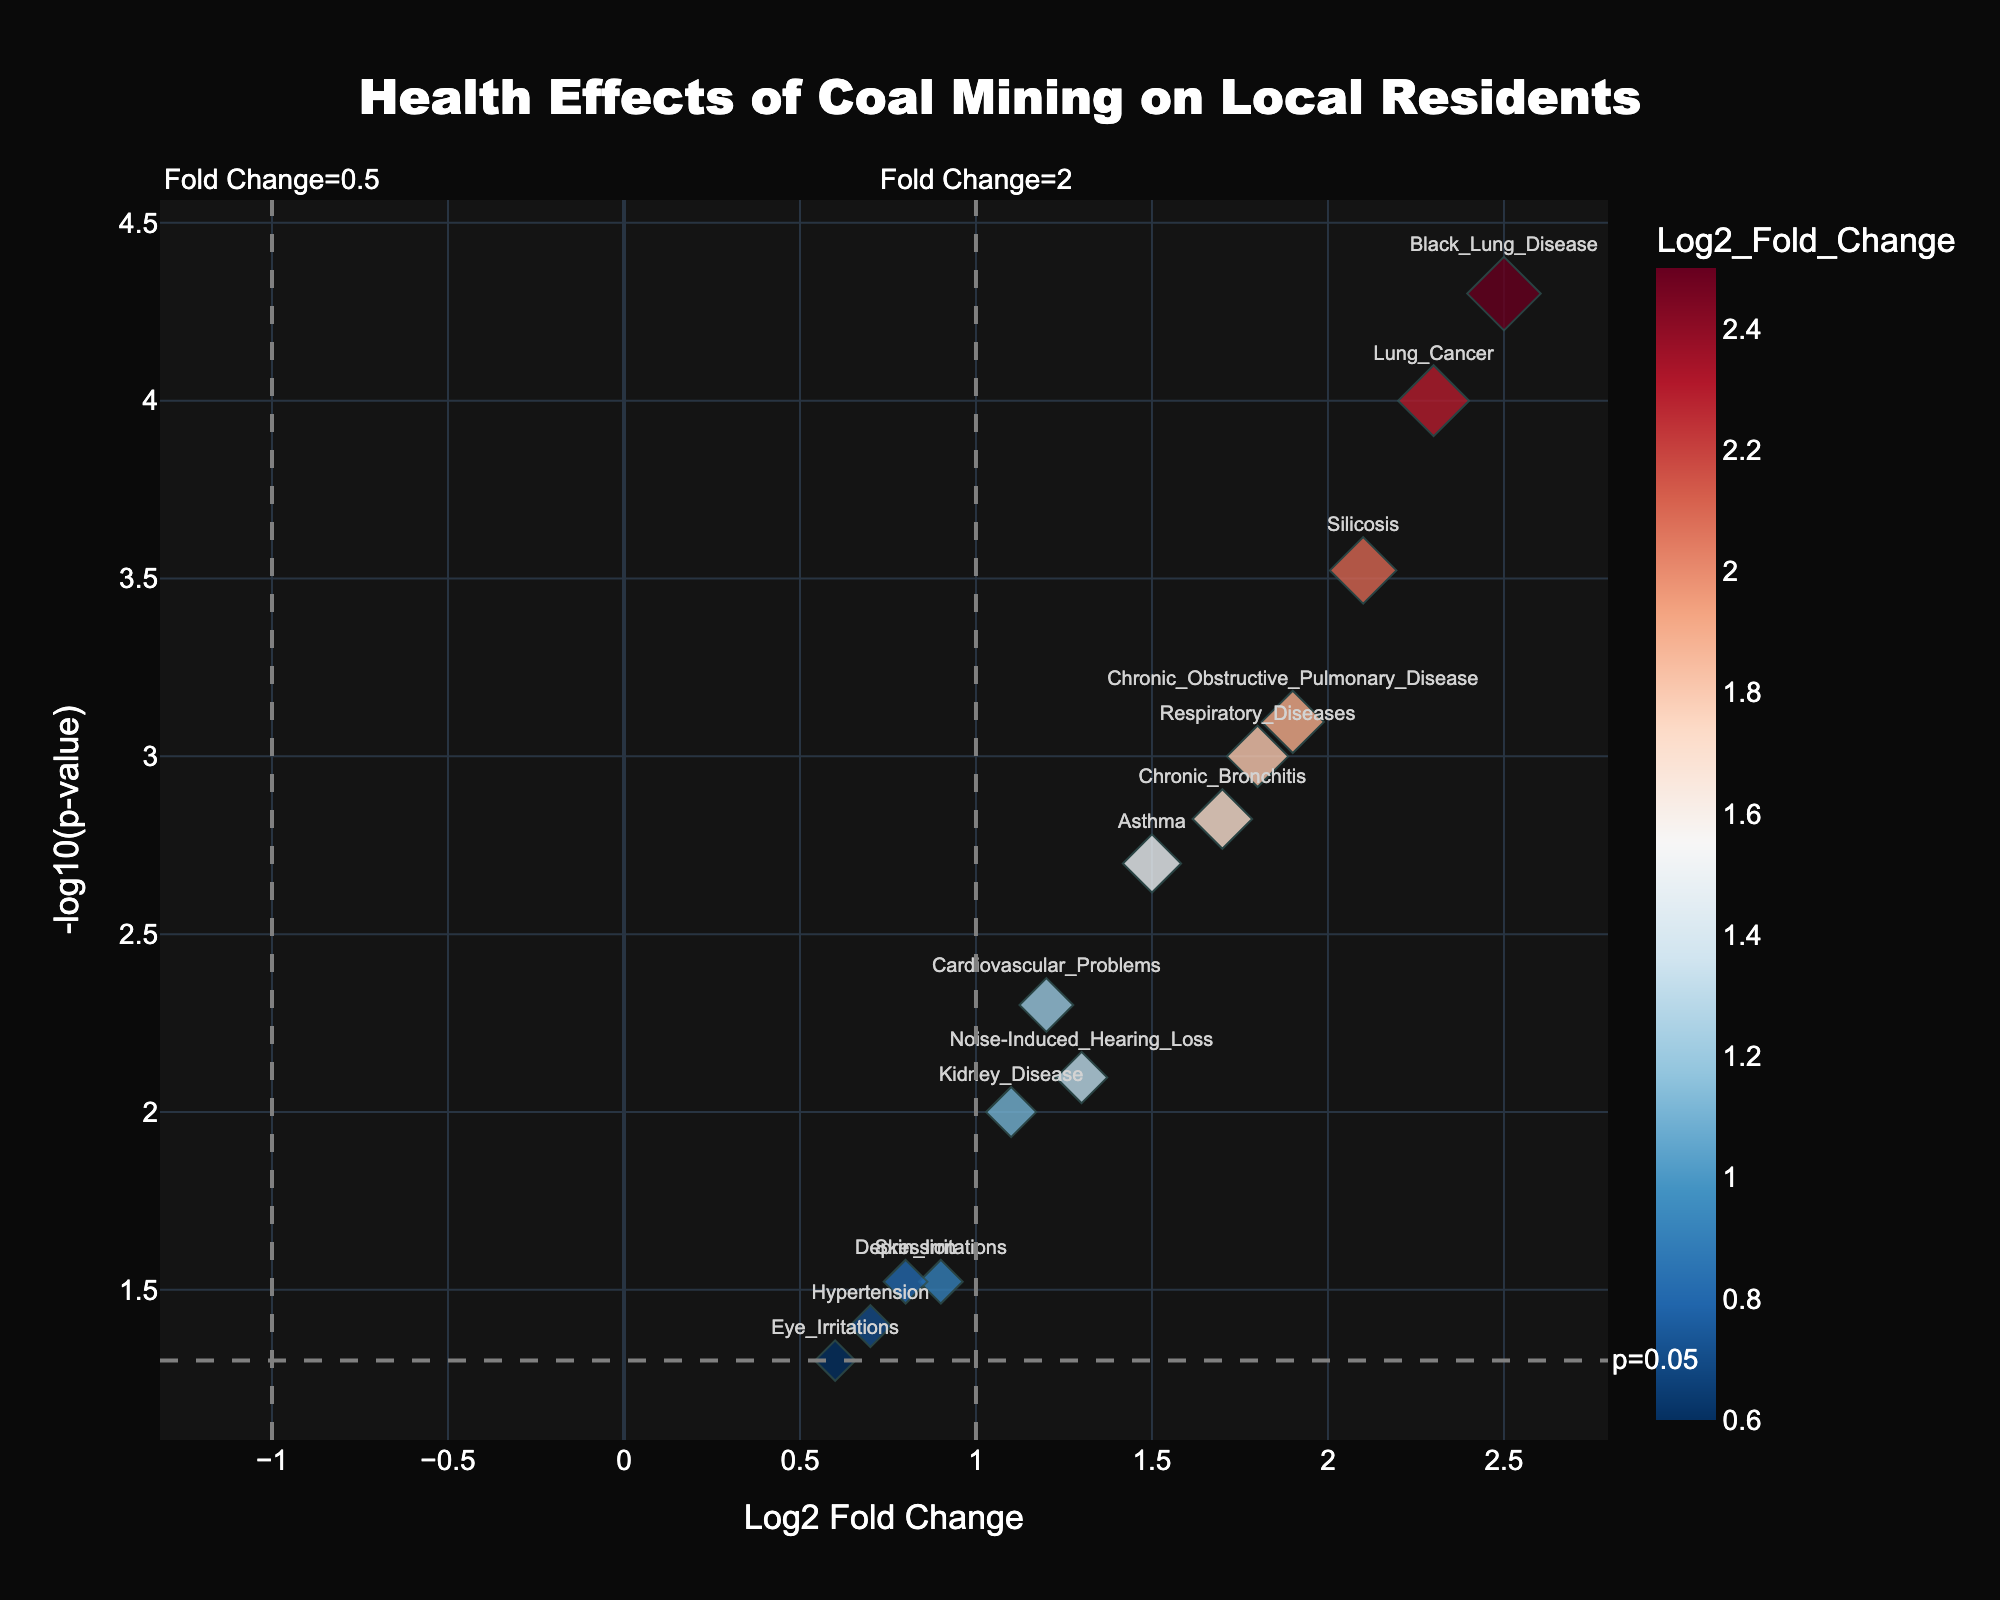What is the title of the plot? The title of the plot is typically displayed at the top of the figure. In this case, it is "Health Effects of Coal Mining on Local Residents" as referenced in the code.
Answer: Health Effects of Coal Mining on Local Residents How many health issues have a p-value less than 0.05? A p-value less than 0.05 is considered statistically significant. By counting the number of data points above the horizontal line labeled "p=0.05", we can determine the number of health issues that meet this criterion.
Answer: 12 Which health issue has the highest magnitude of log2 fold change? The log2 fold change is on the x-axis. The health issue with the highest log2 fold change will be the data point farthest to the right. From the data, this is Black Lung Disease with a log2 fold change of 2.5.
Answer: Black Lung Disease What are the health issues with log2 fold change greater than 2? Data points with log2 fold change > 2 lie to the right of the vertical line labeled "Fold Change=2". These health issues are identified from the figure by their labels.
Answer: Lung Cancer, Black Lung Disease, Silicosis For health issues with a log2 fold change greater than 2, what is their average -log10(p-value)? First identify the health issues with log2 fold change > 2 (Lung Cancer, Black Lung Disease, Silicosis). Then sum their -log10(p-values) and divide by the number of such health issues.
Answer: 3.72 What health issue has the smallest -log10(p-value)? The y-axis shows -log10(p-value), with smaller values lower on the plot. Eye Irritations, which is closest to the x-axis, has the smallest -log10(p-value).
Answer: Eye Irritations How many health issues have a log2 fold change between 1 and 2? This includes data points that lie between the vertical lines at log2 fold change = 1 and log2 fold change = 2. Count the data points in this range.
Answer: 5 Which health issue has the combination of high log2 fold change and high statistical significance? High log2 fold change means a value far from zero, and high statistical significance means a high -log10(p-value). The health issue that combines both of these properties will be furthest to the right and highest up.
Answer: Black Lung Disease 